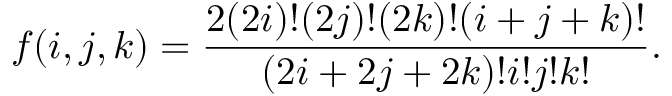<formula> <loc_0><loc_0><loc_500><loc_500>f ( i , j , k ) = \frac { 2 ( 2 i ) ! ( 2 j ) ! ( 2 k ) ! ( i + j + k ) ! } { ( 2 i + 2 j + 2 k ) ! i ! j ! k ! } .</formula> 